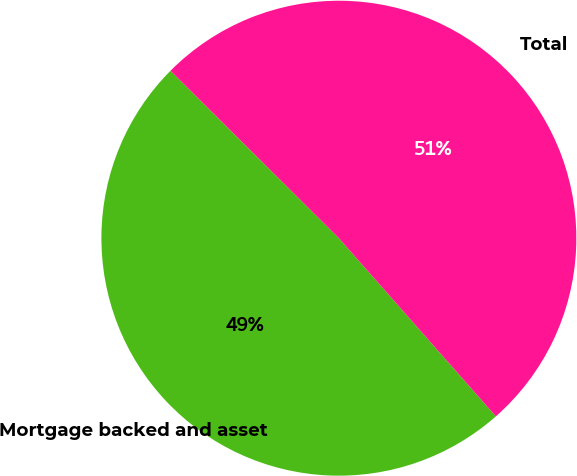Convert chart. <chart><loc_0><loc_0><loc_500><loc_500><pie_chart><fcel>Mortgage backed and asset<fcel>Total<nl><fcel>48.95%<fcel>51.05%<nl></chart> 